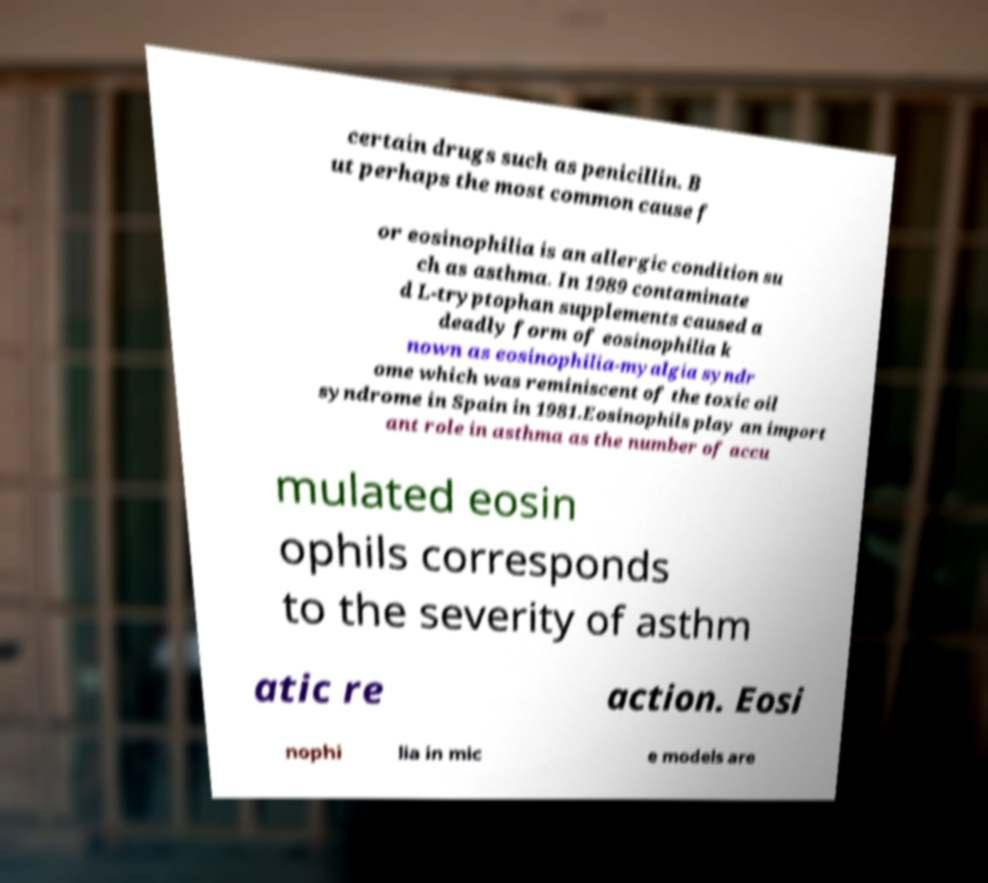There's text embedded in this image that I need extracted. Can you transcribe it verbatim? certain drugs such as penicillin. B ut perhaps the most common cause f or eosinophilia is an allergic condition su ch as asthma. In 1989 contaminate d L-tryptophan supplements caused a deadly form of eosinophilia k nown as eosinophilia-myalgia syndr ome which was reminiscent of the toxic oil syndrome in Spain in 1981.Eosinophils play an import ant role in asthma as the number of accu mulated eosin ophils corresponds to the severity of asthm atic re action. Eosi nophi lia in mic e models are 